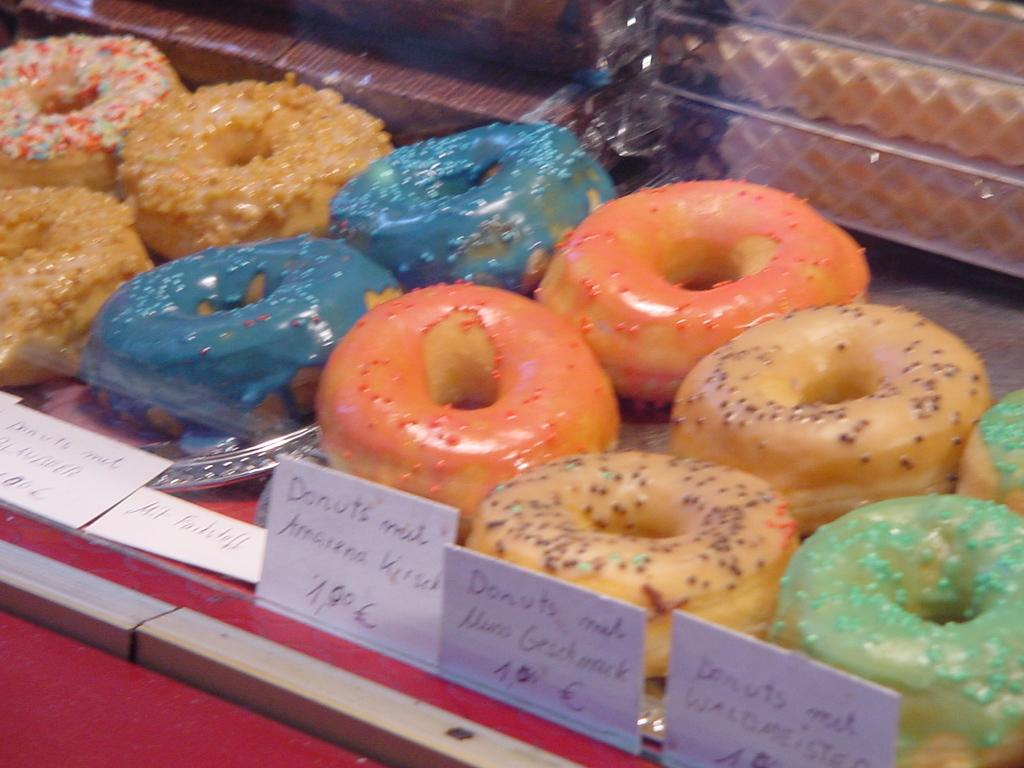What type of food is featured in the image? There are many donuts in the image. How do the donuts differ from one another? The donuts have different colors. What additional information is provided about the donuts in the image? There is a name and price tag in the image. How far can the donuts fly in the image? The donuts cannot fly in the image, as they are stationary food items. 